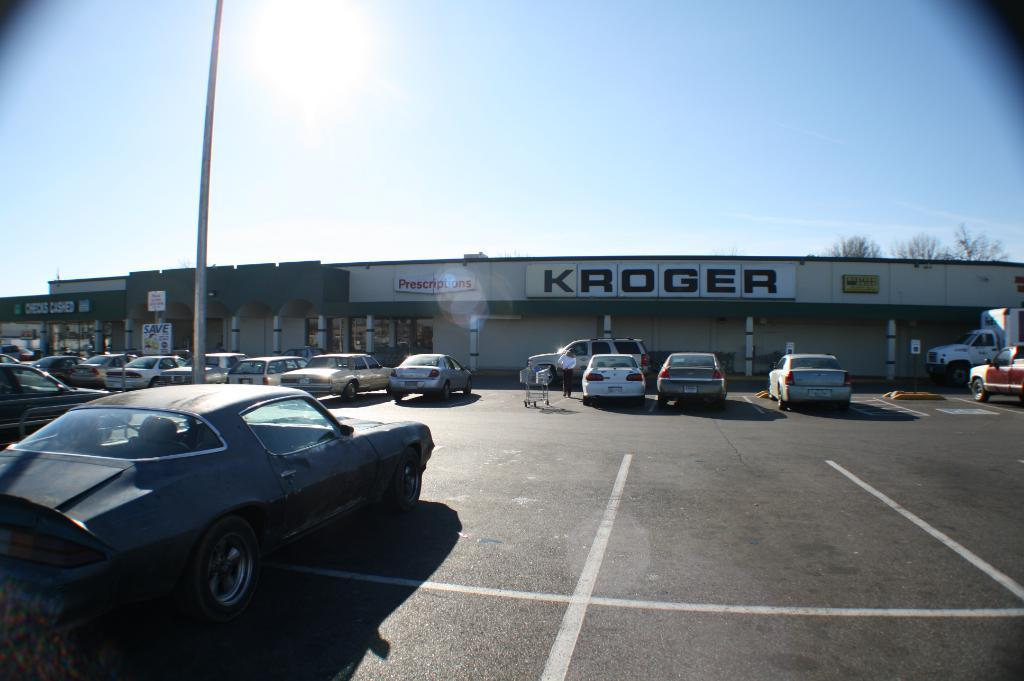What type of vehicles can be seen on the road in the image? There are cars on the road in the image. What other mode of transportation is present in the image? There is a trolley in the image. Can you describe the person visible in the image? A person is visible in the image. What is located on the left side of the image? There is a pole on the left side of the image. What can be seen in the background of the image? There is a building, trees, and the sky visible in the background of the image. Reasoning: Let' Let's think step by step in order to produce the conversation. We start by identifying the main subjects and objects in the image based on the provided facts. We then formulate questions that focus on the location and characteristics of these subjects and objects, ensuring that each question can be answered definitively with the information given. We avoid yes/no questions and ensure that the language is simple and clear. Absurd Question/Answer: How many balls are being stitched by the spiders in the image? There are no spiders or balls present in the image. What type of stitch is being used by the spiders to create the ball in the image? There is no ball or spider present in the image, so it is not possible to determine the type of stitch being used. 